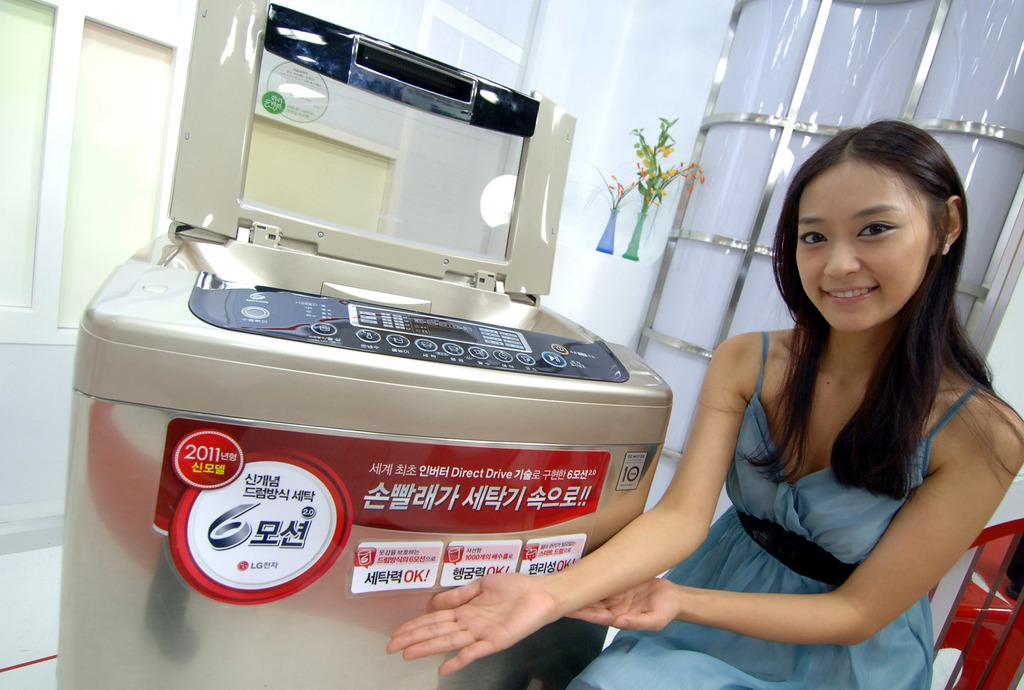<image>
Share a concise interpretation of the image provided. A woman shows off a machine that has stickers saying 2011 and OK! as well as many things in foreign languages on it. 